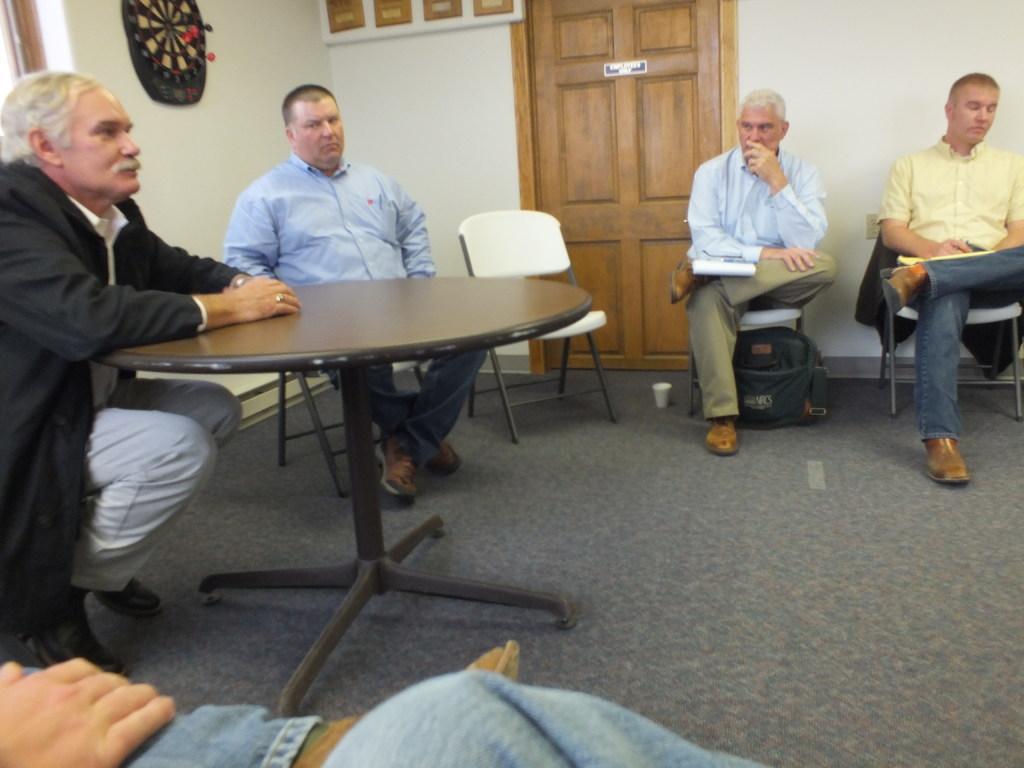Can you describe this image briefly? there are so many people sitting in shape in front of a table behind then there is an arrow game on the wall and a door. 